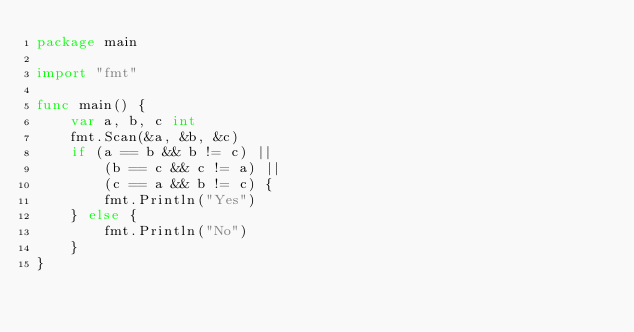Convert code to text. <code><loc_0><loc_0><loc_500><loc_500><_Go_>package main

import "fmt"

func main() {
	var a, b, c int
	fmt.Scan(&a, &b, &c)
	if (a == b && b != c) ||
		(b == c && c != a) ||
		(c == a && b != c) {
		fmt.Println("Yes")
	} else {
		fmt.Println("No")
	}
}
</code> 